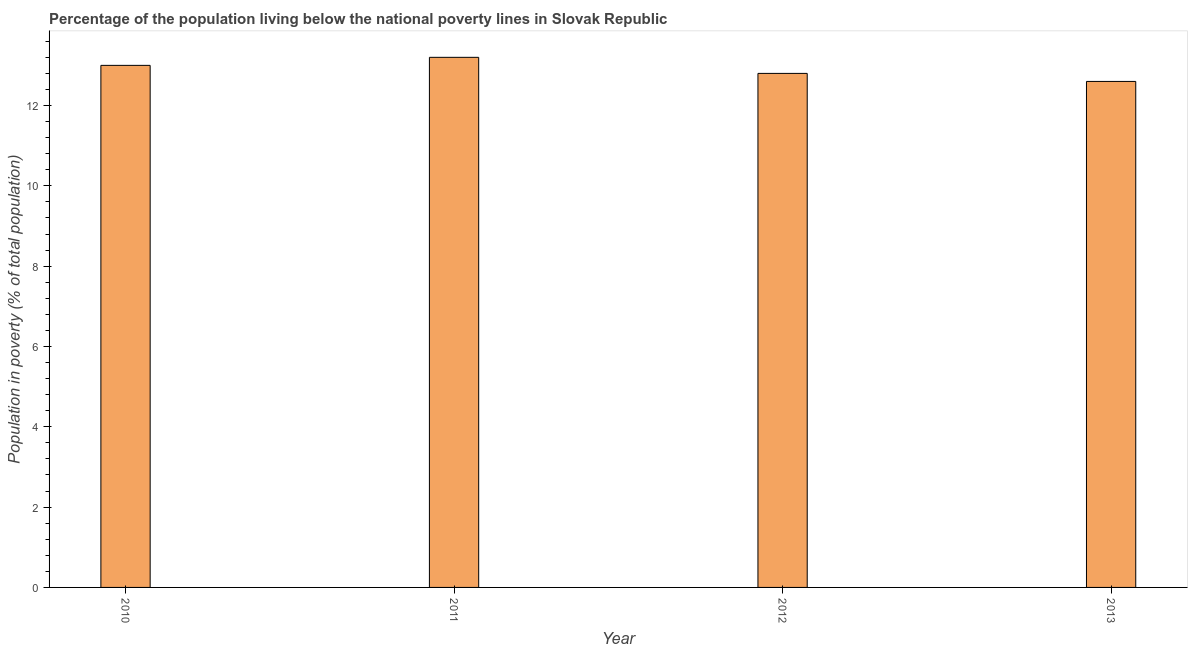Does the graph contain grids?
Keep it short and to the point. No. What is the title of the graph?
Ensure brevity in your answer.  Percentage of the population living below the national poverty lines in Slovak Republic. What is the label or title of the Y-axis?
Make the answer very short. Population in poverty (% of total population). What is the percentage of population living below poverty line in 2011?
Provide a succinct answer. 13.2. Across all years, what is the minimum percentage of population living below poverty line?
Keep it short and to the point. 12.6. In which year was the percentage of population living below poverty line maximum?
Your answer should be very brief. 2011. In which year was the percentage of population living below poverty line minimum?
Your answer should be compact. 2013. What is the sum of the percentage of population living below poverty line?
Make the answer very short. 51.6. What is the median percentage of population living below poverty line?
Offer a very short reply. 12.9. Do a majority of the years between 2011 and 2012 (inclusive) have percentage of population living below poverty line greater than 2 %?
Your response must be concise. Yes. What is the ratio of the percentage of population living below poverty line in 2010 to that in 2011?
Your response must be concise. 0.98. Is the difference between the percentage of population living below poverty line in 2010 and 2013 greater than the difference between any two years?
Your answer should be compact. No. What is the difference between the highest and the second highest percentage of population living below poverty line?
Your answer should be very brief. 0.2. In how many years, is the percentage of population living below poverty line greater than the average percentage of population living below poverty line taken over all years?
Give a very brief answer. 2. How many bars are there?
Give a very brief answer. 4. Are all the bars in the graph horizontal?
Offer a very short reply. No. What is the Population in poverty (% of total population) of 2012?
Keep it short and to the point. 12.8. What is the difference between the Population in poverty (% of total population) in 2010 and 2012?
Your answer should be very brief. 0.2. What is the difference between the Population in poverty (% of total population) in 2010 and 2013?
Your answer should be very brief. 0.4. What is the difference between the Population in poverty (% of total population) in 2011 and 2012?
Ensure brevity in your answer.  0.4. What is the difference between the Population in poverty (% of total population) in 2012 and 2013?
Provide a succinct answer. 0.2. What is the ratio of the Population in poverty (% of total population) in 2010 to that in 2012?
Give a very brief answer. 1.02. What is the ratio of the Population in poverty (% of total population) in 2010 to that in 2013?
Offer a terse response. 1.03. What is the ratio of the Population in poverty (% of total population) in 2011 to that in 2012?
Ensure brevity in your answer.  1.03. What is the ratio of the Population in poverty (% of total population) in 2011 to that in 2013?
Your answer should be very brief. 1.05. 